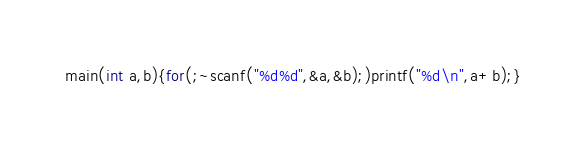<code> <loc_0><loc_0><loc_500><loc_500><_C++_>main(int a,b){for(;~scanf("%d%d",&a,&b);)printf("%d\n",a+b);}</code> 